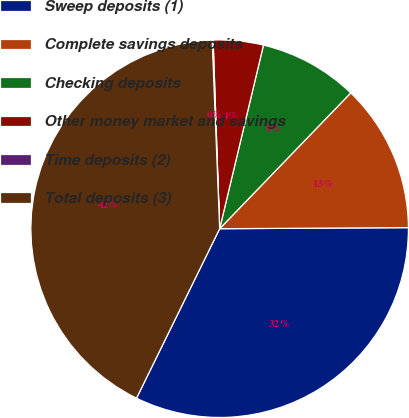Convert chart to OTSL. <chart><loc_0><loc_0><loc_500><loc_500><pie_chart><fcel>Sweep deposits (1)<fcel>Complete savings deposits<fcel>Checking deposits<fcel>Other money market and savings<fcel>Time deposits (2)<fcel>Total deposits (3)<nl><fcel>32.35%<fcel>12.69%<fcel>8.49%<fcel>4.28%<fcel>0.08%<fcel>42.11%<nl></chart> 